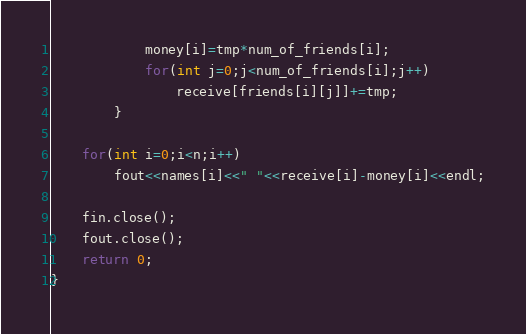<code> <loc_0><loc_0><loc_500><loc_500><_C++_>			money[i]=tmp*num_of_friends[i];
			for(int j=0;j<num_of_friends[i];j++)
				receive[friends[i][j]]+=tmp;
		}

	for(int i=0;i<n;i++)
		fout<<names[i]<<" "<<receive[i]-money[i]<<endl;

	fin.close();
	fout.close();
	return 0;
}
</code> 